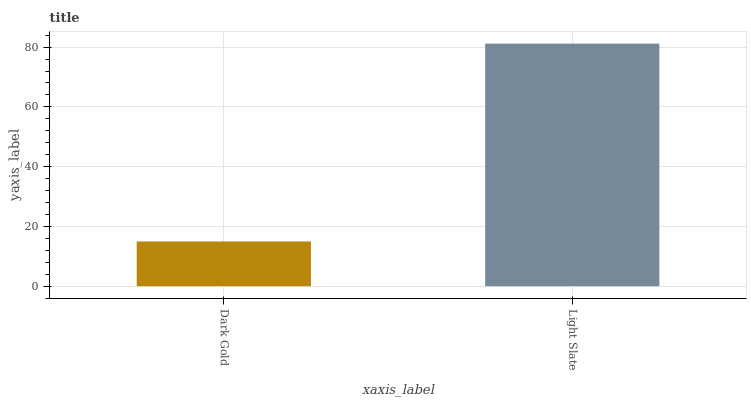Is Light Slate the minimum?
Answer yes or no. No. Is Light Slate greater than Dark Gold?
Answer yes or no. Yes. Is Dark Gold less than Light Slate?
Answer yes or no. Yes. Is Dark Gold greater than Light Slate?
Answer yes or no. No. Is Light Slate less than Dark Gold?
Answer yes or no. No. Is Light Slate the high median?
Answer yes or no. Yes. Is Dark Gold the low median?
Answer yes or no. Yes. Is Dark Gold the high median?
Answer yes or no. No. Is Light Slate the low median?
Answer yes or no. No. 